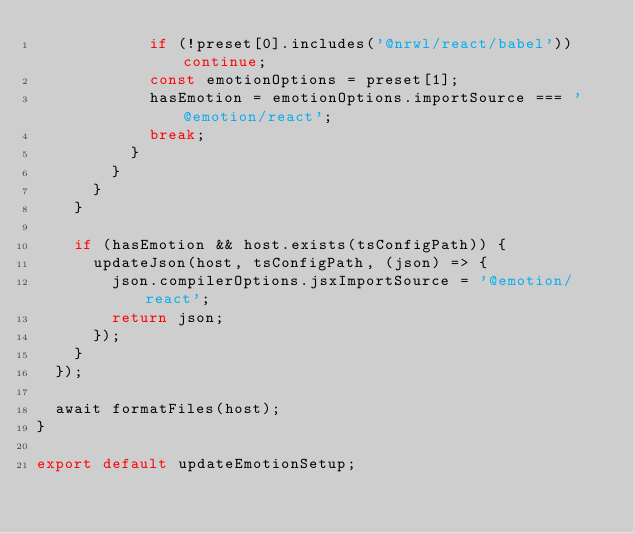Convert code to text. <code><loc_0><loc_0><loc_500><loc_500><_TypeScript_>            if (!preset[0].includes('@nrwl/react/babel')) continue;
            const emotionOptions = preset[1];
            hasEmotion = emotionOptions.importSource === '@emotion/react';
            break;
          }
        }
      }
    }

    if (hasEmotion && host.exists(tsConfigPath)) {
      updateJson(host, tsConfigPath, (json) => {
        json.compilerOptions.jsxImportSource = '@emotion/react';
        return json;
      });
    }
  });

  await formatFiles(host);
}

export default updateEmotionSetup;
</code> 